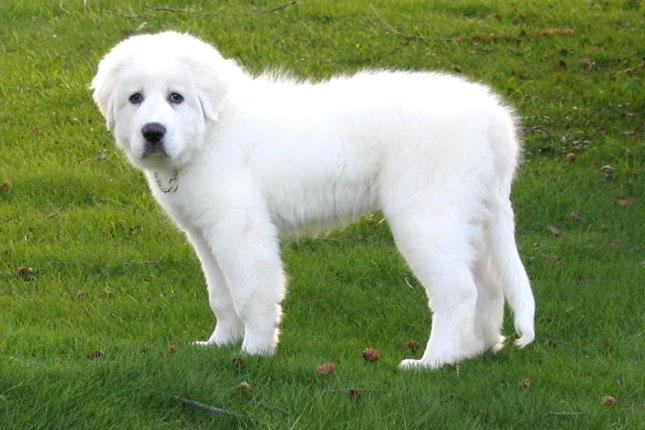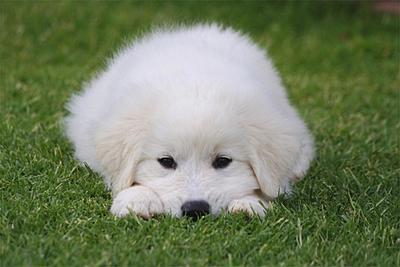The first image is the image on the left, the second image is the image on the right. Considering the images on both sides, is "There is at least one dog not in the grass" valid? Answer yes or no. No. The first image is the image on the left, the second image is the image on the right. Analyze the images presented: Is the assertion "In one image there is a white dog outside in the grass." valid? Answer yes or no. No. 